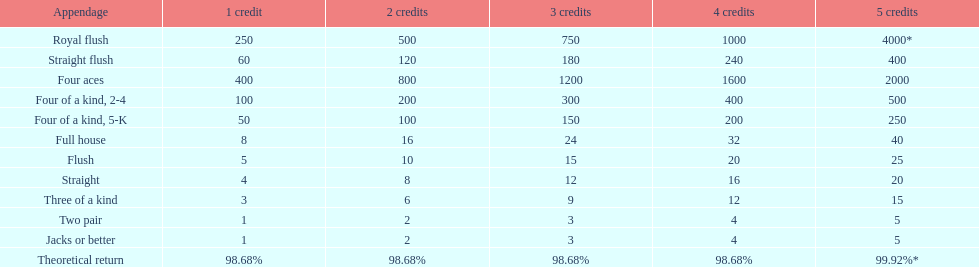How many straight wins at 3 credits equals one straight flush win at two credits? 10. 